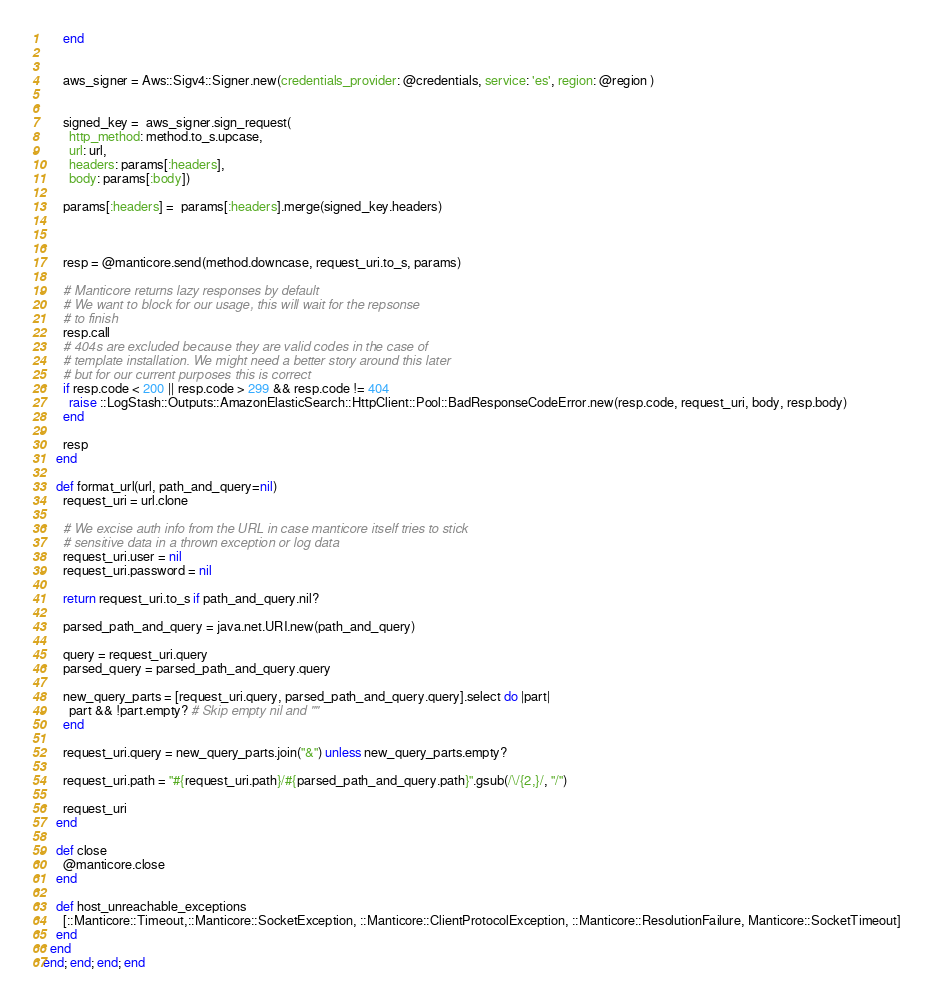<code> <loc_0><loc_0><loc_500><loc_500><_Ruby_>      end


      aws_signer = Aws::Sigv4::Signer.new(credentials_provider: @credentials, service: 'es', region: @region )


      signed_key =  aws_signer.sign_request(
        http_method: method.to_s.upcase,
        url: url,
        headers: params[:headers],
        body: params[:body])

      params[:headers] =  params[:headers].merge(signed_key.headers)



      resp = @manticore.send(method.downcase, request_uri.to_s, params)

      # Manticore returns lazy responses by default
      # We want to block for our usage, this will wait for the repsonse
      # to finish
      resp.call
      # 404s are excluded because they are valid codes in the case of
      # template installation. We might need a better story around this later
      # but for our current purposes this is correct
      if resp.code < 200 || resp.code > 299 && resp.code != 404
        raise ::LogStash::Outputs::AmazonElasticSearch::HttpClient::Pool::BadResponseCodeError.new(resp.code, request_uri, body, resp.body)
      end

      resp
    end

    def format_url(url, path_and_query=nil)
      request_uri = url.clone

      # We excise auth info from the URL in case manticore itself tries to stick
      # sensitive data in a thrown exception or log data
      request_uri.user = nil
      request_uri.password = nil

      return request_uri.to_s if path_and_query.nil?

      parsed_path_and_query = java.net.URI.new(path_and_query)

      query = request_uri.query
      parsed_query = parsed_path_and_query.query

      new_query_parts = [request_uri.query, parsed_path_and_query.query].select do |part|
        part && !part.empty? # Skip empty nil and ""
      end

      request_uri.query = new_query_parts.join("&") unless new_query_parts.empty?

      request_uri.path = "#{request_uri.path}/#{parsed_path_and_query.path}".gsub(/\/{2,}/, "/")

      request_uri
    end

    def close
      @manticore.close
    end

    def host_unreachable_exceptions
      [::Manticore::Timeout,::Manticore::SocketException, ::Manticore::ClientProtocolException, ::Manticore::ResolutionFailure, Manticore::SocketTimeout]
    end
  end
end; end; end; end
</code> 